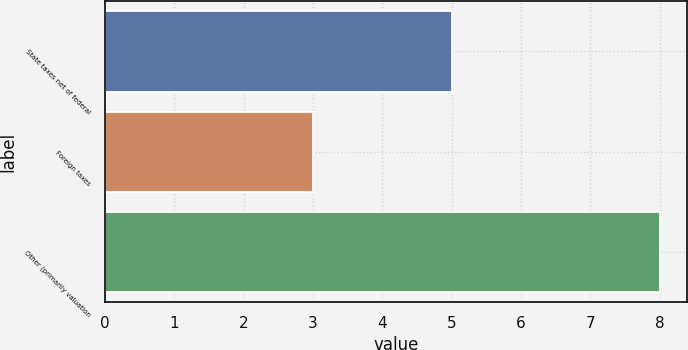Convert chart. <chart><loc_0><loc_0><loc_500><loc_500><bar_chart><fcel>State taxes net of federal<fcel>Foreign taxes<fcel>Other (primarily valuation<nl><fcel>5<fcel>3<fcel>8<nl></chart> 